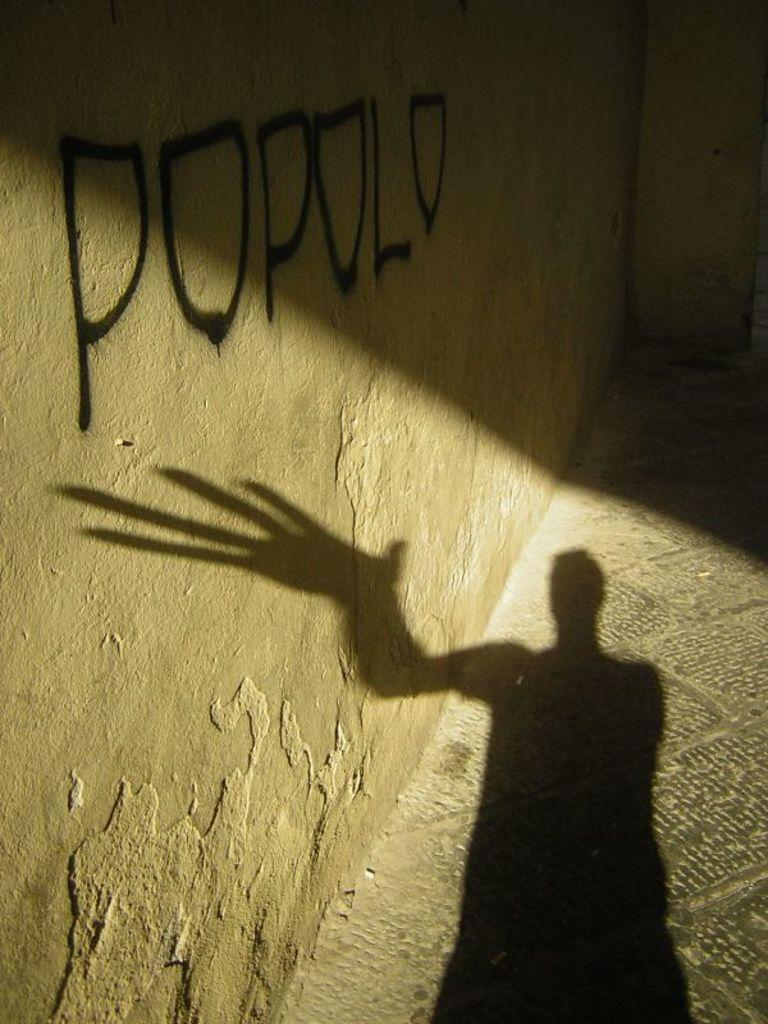What can be seen on the floor in the image? There is a shadow of a person on the floor in the image. What is located on the left side of the floor in the image? There is a wall on the left side of the floor in the image. What type of wave can be seen crashing on the shore in the image? There is no wave or shore present in the image; it only features a shadow of a person on the floor and a wall on the left side. 